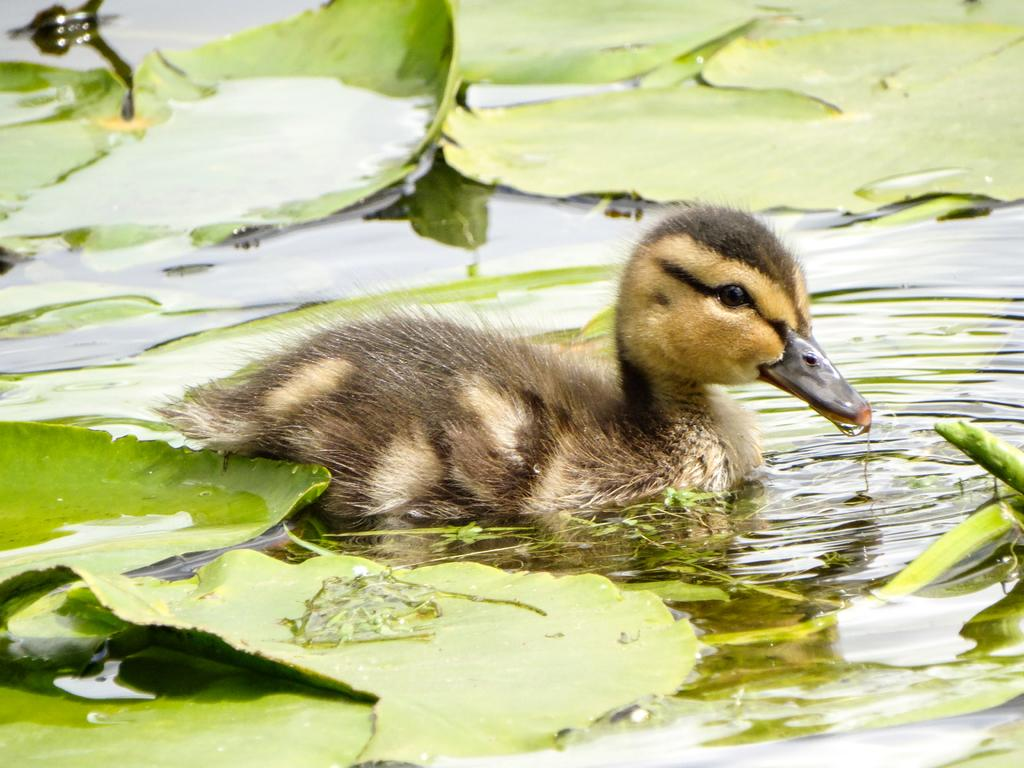What type of animal can be seen in the picture? There is a bird in the picture. What else is present in the picture besides the bird? There are leaves and water visible in the picture. What type of battle is taking place in the picture? There is no battle present in the picture; it features a bird, leaves, and water. Can you see a hand holding the bird in the picture? There is no hand holding the bird in the picture; it is perched or flying. 